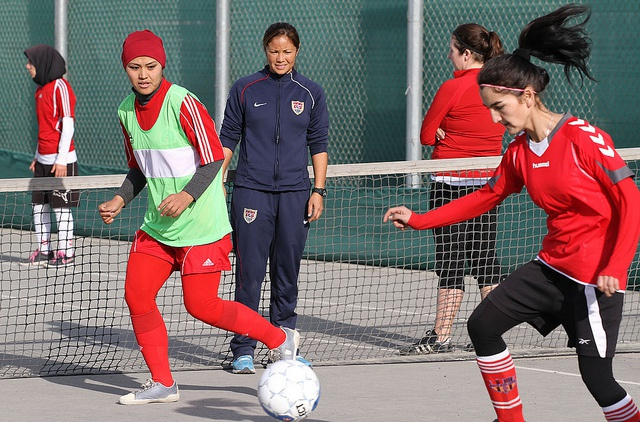Describe the objects in this image and their specific colors. I can see people in teal, black, red, brown, and maroon tones, people in teal, red, lightgreen, ivory, and gray tones, people in teal, navy, black, gray, and blue tones, people in teal, black, red, and gray tones, and people in teal, black, white, red, and gray tones in this image. 